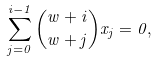<formula> <loc_0><loc_0><loc_500><loc_500>\sum _ { j = 0 } ^ { i - 1 } { w + i \choose w + j } x _ { j } = 0 ,</formula> 